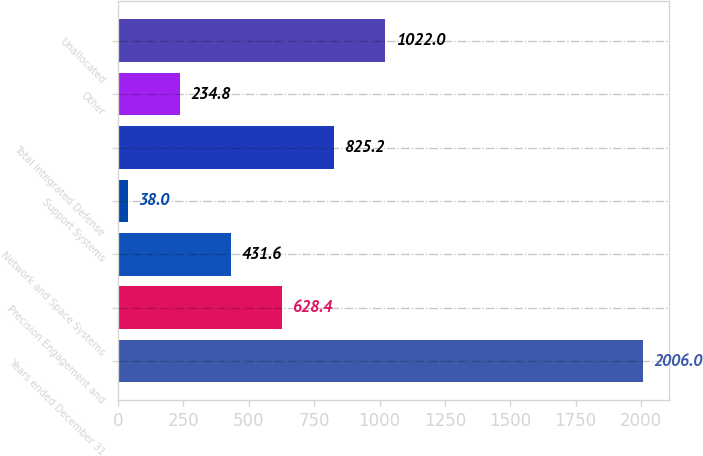<chart> <loc_0><loc_0><loc_500><loc_500><bar_chart><fcel>Years ended December 31<fcel>Precision Engagement and<fcel>Network and Space Systems<fcel>Support Systems<fcel>Total Integrated Defense<fcel>Other<fcel>Unallocated<nl><fcel>2006<fcel>628.4<fcel>431.6<fcel>38<fcel>825.2<fcel>234.8<fcel>1022<nl></chart> 